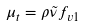<formula> <loc_0><loc_0><loc_500><loc_500>\mu _ { t } = \rho \tilde { \nu } f _ { v 1 }</formula> 